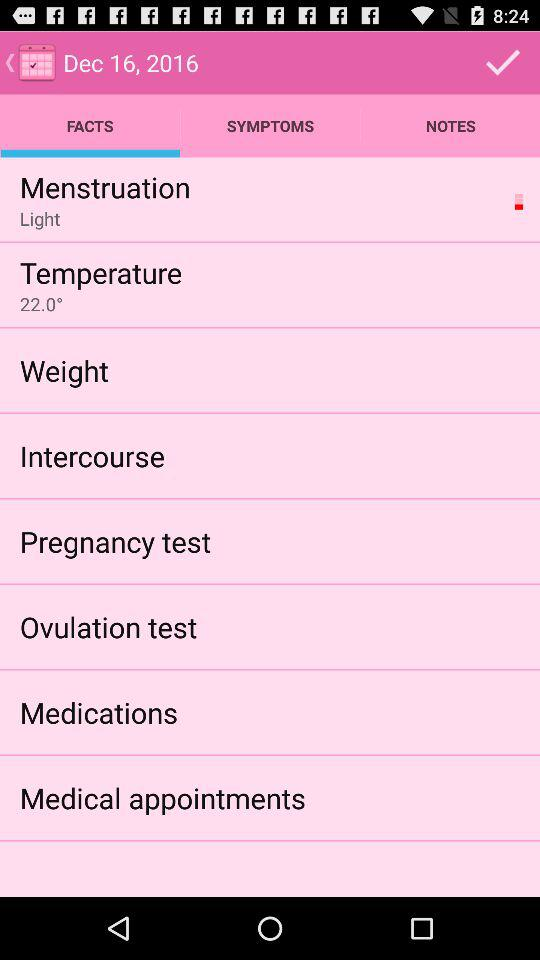What is the temperature?
Answer the question using a single word or phrase. 22.0° 